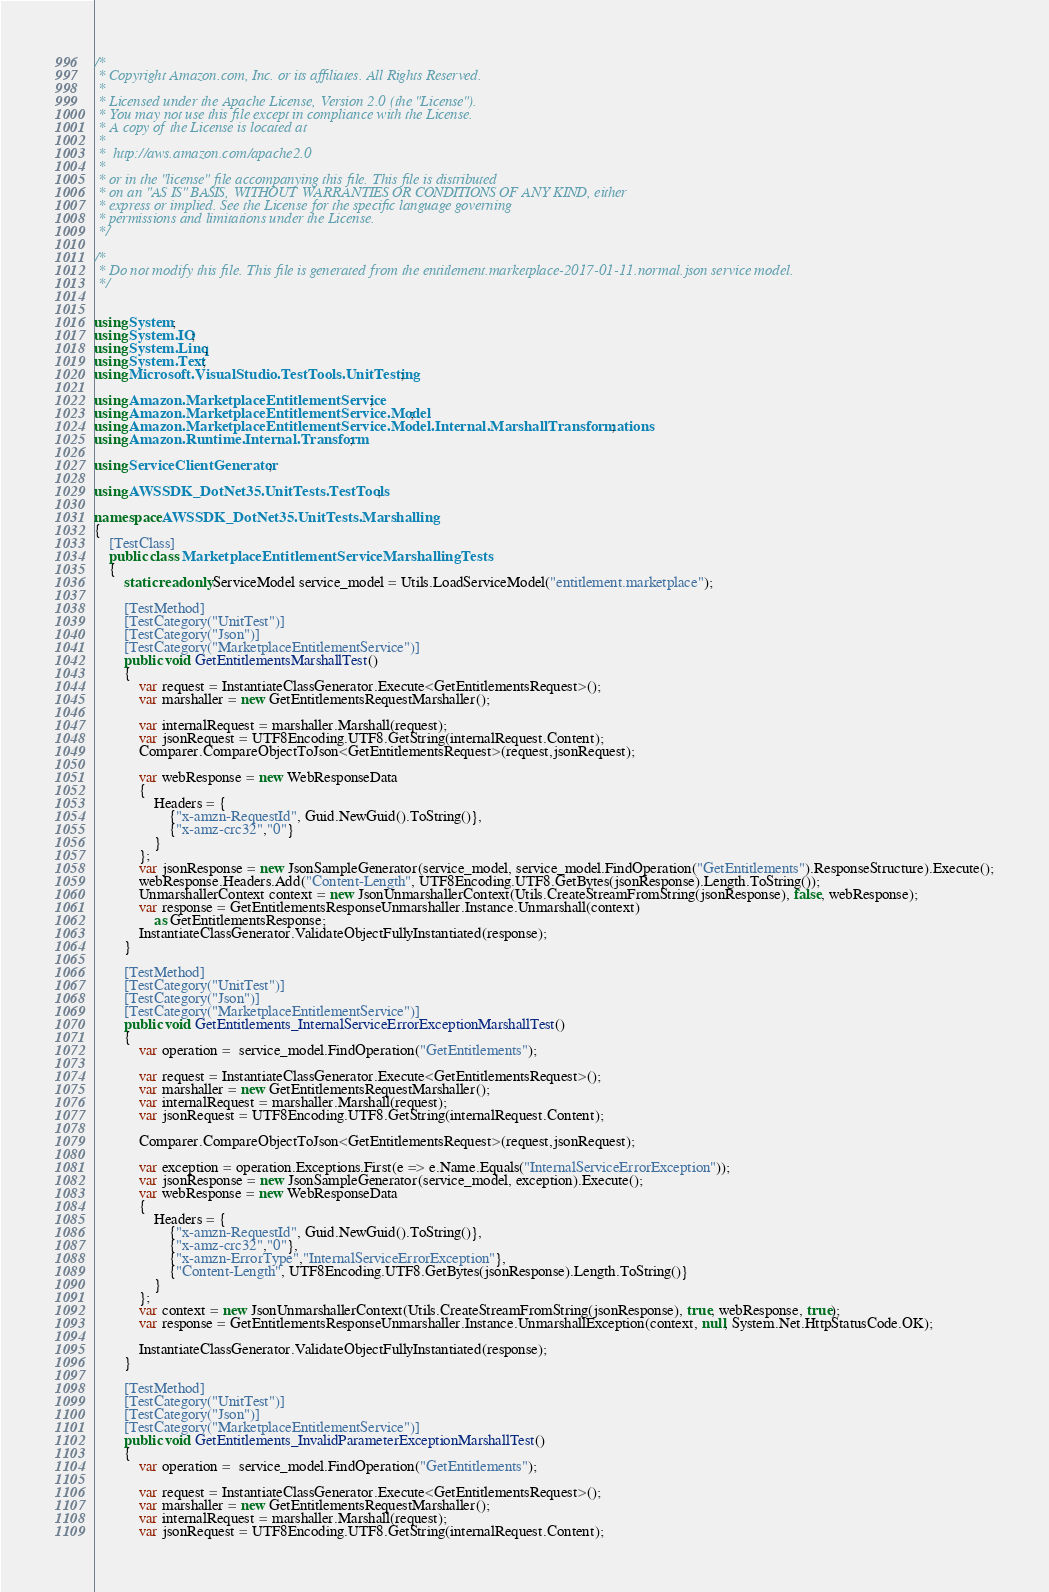Convert code to text. <code><loc_0><loc_0><loc_500><loc_500><_C#_>/*
 * Copyright Amazon.com, Inc. or its affiliates. All Rights Reserved.
 * 
 * Licensed under the Apache License, Version 2.0 (the "License").
 * You may not use this file except in compliance with the License.
 * A copy of the License is located at
 * 
 *  http://aws.amazon.com/apache2.0
 * 
 * or in the "license" file accompanying this file. This file is distributed
 * on an "AS IS" BASIS, WITHOUT WARRANTIES OR CONDITIONS OF ANY KIND, either
 * express or implied. See the License for the specific language governing
 * permissions and limitations under the License.
 */

/*
 * Do not modify this file. This file is generated from the entitlement.marketplace-2017-01-11.normal.json service model.
 */


using System;
using System.IO;
using System.Linq;
using System.Text;
using Microsoft.VisualStudio.TestTools.UnitTesting;

using Amazon.MarketplaceEntitlementService;
using Amazon.MarketplaceEntitlementService.Model;
using Amazon.MarketplaceEntitlementService.Model.Internal.MarshallTransformations;
using Amazon.Runtime.Internal.Transform;

using ServiceClientGenerator;

using AWSSDK_DotNet35.UnitTests.TestTools;

namespace AWSSDK_DotNet35.UnitTests.Marshalling
{
    [TestClass]
    public class MarketplaceEntitlementServiceMarshallingTests
    {
        static readonly ServiceModel service_model = Utils.LoadServiceModel("entitlement.marketplace");
        
        [TestMethod]
        [TestCategory("UnitTest")]
        [TestCategory("Json")]
        [TestCategory("MarketplaceEntitlementService")]
        public void GetEntitlementsMarshallTest()
        {
            var request = InstantiateClassGenerator.Execute<GetEntitlementsRequest>();
            var marshaller = new GetEntitlementsRequestMarshaller();

            var internalRequest = marshaller.Marshall(request);
            var jsonRequest = UTF8Encoding.UTF8.GetString(internalRequest.Content);                        
            Comparer.CompareObjectToJson<GetEntitlementsRequest>(request,jsonRequest);

            var webResponse = new WebResponseData
            {
                Headers = {
                    {"x-amzn-RequestId", Guid.NewGuid().ToString()},
                    {"x-amz-crc32","0"}
                }
            };
            var jsonResponse = new JsonSampleGenerator(service_model, service_model.FindOperation("GetEntitlements").ResponseStructure).Execute();
            webResponse.Headers.Add("Content-Length", UTF8Encoding.UTF8.GetBytes(jsonResponse).Length.ToString());
            UnmarshallerContext context = new JsonUnmarshallerContext(Utils.CreateStreamFromString(jsonResponse), false, webResponse);
            var response = GetEntitlementsResponseUnmarshaller.Instance.Unmarshall(context)
                as GetEntitlementsResponse;
            InstantiateClassGenerator.ValidateObjectFullyInstantiated(response);
        }

        [TestMethod]
        [TestCategory("UnitTest")]
        [TestCategory("Json")]
        [TestCategory("MarketplaceEntitlementService")]
        public void GetEntitlements_InternalServiceErrorExceptionMarshallTest()
        {
            var operation =  service_model.FindOperation("GetEntitlements");

            var request = InstantiateClassGenerator.Execute<GetEntitlementsRequest>();
            var marshaller = new GetEntitlementsRequestMarshaller();
            var internalRequest = marshaller.Marshall(request);
            var jsonRequest = UTF8Encoding.UTF8.GetString(internalRequest.Content);

            Comparer.CompareObjectToJson<GetEntitlementsRequest>(request,jsonRequest);

            var exception = operation.Exceptions.First(e => e.Name.Equals("InternalServiceErrorException"));
            var jsonResponse = new JsonSampleGenerator(service_model, exception).Execute();
            var webResponse = new WebResponseData
            {
                Headers = {
                    {"x-amzn-RequestId", Guid.NewGuid().ToString()},
                    {"x-amz-crc32","0"},
                    {"x-amzn-ErrorType","InternalServiceErrorException"},
                    {"Content-Length", UTF8Encoding.UTF8.GetBytes(jsonResponse).Length.ToString()}
                }
            };
            var context = new JsonUnmarshallerContext(Utils.CreateStreamFromString(jsonResponse), true, webResponse, true);
            var response = GetEntitlementsResponseUnmarshaller.Instance.UnmarshallException(context, null, System.Net.HttpStatusCode.OK);

            InstantiateClassGenerator.ValidateObjectFullyInstantiated(response);
        }

        [TestMethod]
        [TestCategory("UnitTest")]
        [TestCategory("Json")]
        [TestCategory("MarketplaceEntitlementService")]
        public void GetEntitlements_InvalidParameterExceptionMarshallTest()
        {
            var operation =  service_model.FindOperation("GetEntitlements");

            var request = InstantiateClassGenerator.Execute<GetEntitlementsRequest>();
            var marshaller = new GetEntitlementsRequestMarshaller();
            var internalRequest = marshaller.Marshall(request);
            var jsonRequest = UTF8Encoding.UTF8.GetString(internalRequest.Content);</code> 